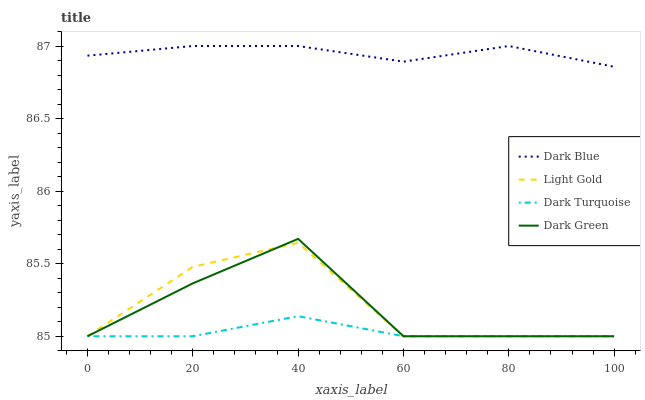Does Dark Turquoise have the minimum area under the curve?
Answer yes or no. Yes. Does Dark Blue have the maximum area under the curve?
Answer yes or no. Yes. Does Dark Green have the minimum area under the curve?
Answer yes or no. No. Does Dark Green have the maximum area under the curve?
Answer yes or no. No. Is Dark Turquoise the smoothest?
Answer yes or no. Yes. Is Light Gold the roughest?
Answer yes or no. Yes. Is Dark Green the smoothest?
Answer yes or no. No. Is Dark Green the roughest?
Answer yes or no. No. Does Dark Green have the lowest value?
Answer yes or no. Yes. Does Dark Blue have the highest value?
Answer yes or no. Yes. Does Dark Green have the highest value?
Answer yes or no. No. Is Dark Green less than Dark Blue?
Answer yes or no. Yes. Is Dark Blue greater than Dark Turquoise?
Answer yes or no. Yes. Does Light Gold intersect Dark Green?
Answer yes or no. Yes. Is Light Gold less than Dark Green?
Answer yes or no. No. Is Light Gold greater than Dark Green?
Answer yes or no. No. Does Dark Green intersect Dark Blue?
Answer yes or no. No. 